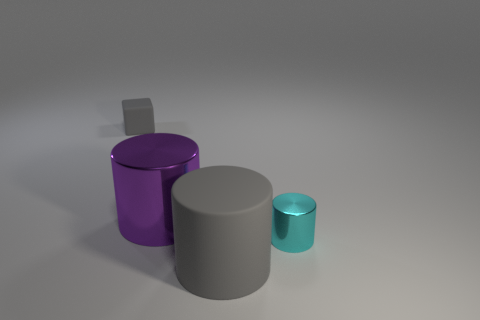Can you describe the shapes and colors present in this image? Certainly! The image features three cylindrical objects. There's a large grey cylinder, a smaller cyan cylinder, and a purple cylinder that is the tallest among them. There's also a very small grey cube in the background, resting partially on the surface and the larger grey cylinder. 